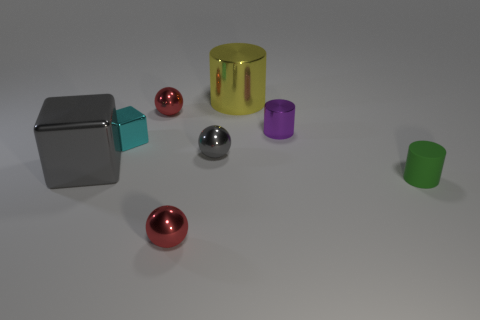What number of cylinders are the same size as the matte thing?
Give a very brief answer. 1. What number of small red things are left of the tiny red metal sphere behind the green cylinder?
Provide a short and direct response. 0. Does the large thing that is in front of the large yellow thing have the same material as the purple cylinder?
Offer a terse response. Yes. Do the purple cylinder behind the gray sphere and the tiny red sphere behind the cyan cube have the same material?
Your answer should be very brief. Yes. Are there more small spheres behind the yellow cylinder than small brown metallic cylinders?
Offer a terse response. No. What is the color of the large shiny thing behind the red object behind the green cylinder?
Your answer should be compact. Yellow. There is a purple shiny object that is the same size as the cyan block; what shape is it?
Offer a terse response. Cylinder. The object that is the same color as the large metal block is what shape?
Provide a short and direct response. Sphere. Is the number of big gray blocks to the right of the rubber cylinder the same as the number of blue objects?
Provide a succinct answer. Yes. There is a tiny red sphere behind the big gray thing to the left of the tiny red metallic thing behind the small rubber cylinder; what is its material?
Provide a short and direct response. Metal. 